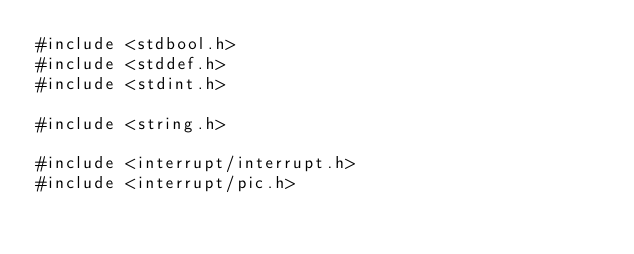<code> <loc_0><loc_0><loc_500><loc_500><_C_>#include <stdbool.h>
#include <stddef.h>
#include <stdint.h>

#include <string.h>

#include <interrupt/interrupt.h>
#include <interrupt/pic.h></code> 